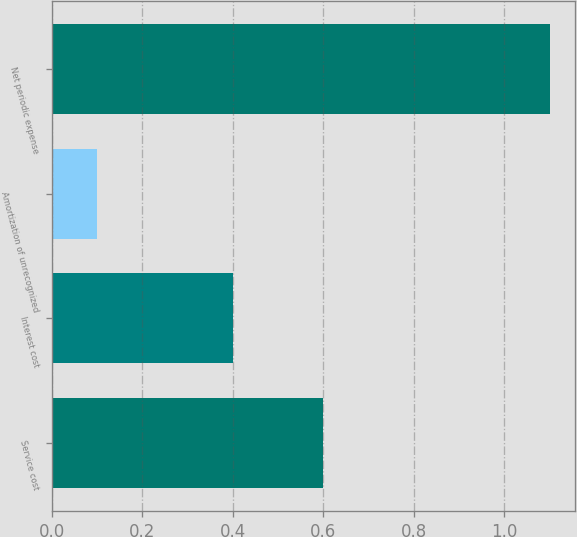Convert chart to OTSL. <chart><loc_0><loc_0><loc_500><loc_500><bar_chart><fcel>Service cost<fcel>Interest cost<fcel>Amortization of unrecognized<fcel>Net periodic expense<nl><fcel>0.6<fcel>0.4<fcel>0.1<fcel>1.1<nl></chart> 